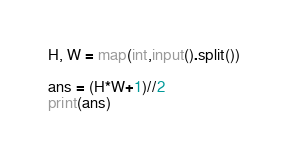<code> <loc_0><loc_0><loc_500><loc_500><_Python_>H, W = map(int,input().split())

ans = (H*W+1)//2
print(ans)</code> 